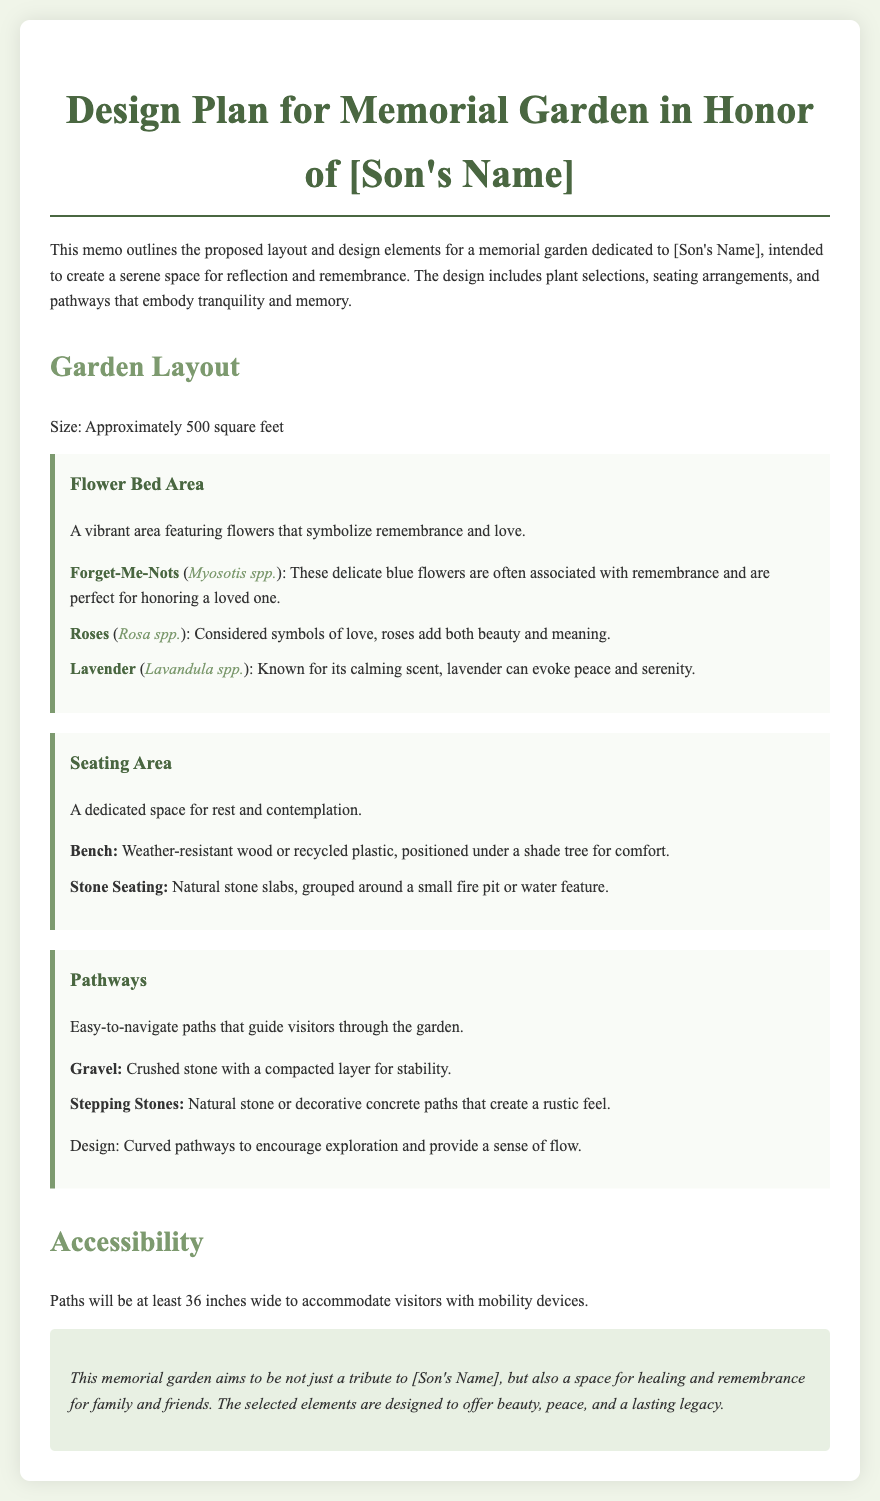What is the size of the memorial garden? The size of the memorial garden is specified in square feet in the document.
Answer: 500 square feet What are the plants listed in the Flower Bed Area? The Flower Bed Area includes specific plants that symbolize remembrance and love.
Answer: Forget-Me-Nots, Roses, Lavender What type of seating is mentioned for the seating area? The seating area describes specific materials and designs for resting spaces in the garden.
Answer: Bench, Stone Seating What is the width requirement for the paths? The document includes a specific measurement for the width of the pathways in the garden.
Answer: 36 inches What is the purpose of the memorial garden? The document outlines the intended purpose of the garden in its introduction.
Answer: Tribute to [Son's Name] What design feature do the pathways encourage? The design aspect of the pathways is mentioned as promoting a specific visitor experience.
Answer: Exploration What material is suggested for the gravel pathway? The document specifies the type of stone used for the paths, detailing its composition.
Answer: Crushed stone What color is the background of the memo? The document provides details on the overall aesthetic and colors used throughout the design.
Answer: #f0f5e9 